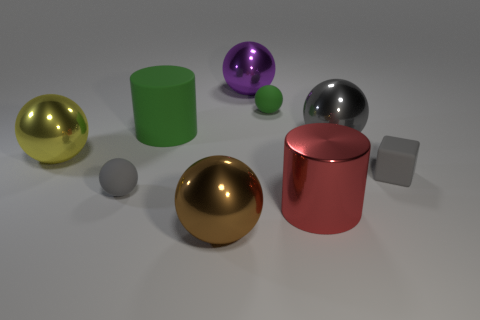What size is the matte ball that is the same color as the rubber cylinder?
Make the answer very short. Small. What is the shape of the thing that is the same color as the matte cylinder?
Make the answer very short. Sphere. How many matte objects are either big purple blocks or gray objects?
Your answer should be very brief. 2. What is the color of the small matte ball in front of the ball right of the big cylinder to the right of the big brown metal ball?
Keep it short and to the point. Gray. There is another matte thing that is the same shape as the big red thing; what color is it?
Make the answer very short. Green. Are there any other things that are the same color as the metallic cylinder?
Give a very brief answer. No. What number of other things are there of the same material as the purple object
Your response must be concise. 4. What is the size of the shiny cylinder?
Ensure brevity in your answer.  Large. Are there any green matte objects that have the same shape as the gray shiny thing?
Provide a short and direct response. Yes. What number of objects are blocks or big metal spheres in front of the large yellow shiny sphere?
Your response must be concise. 2. 